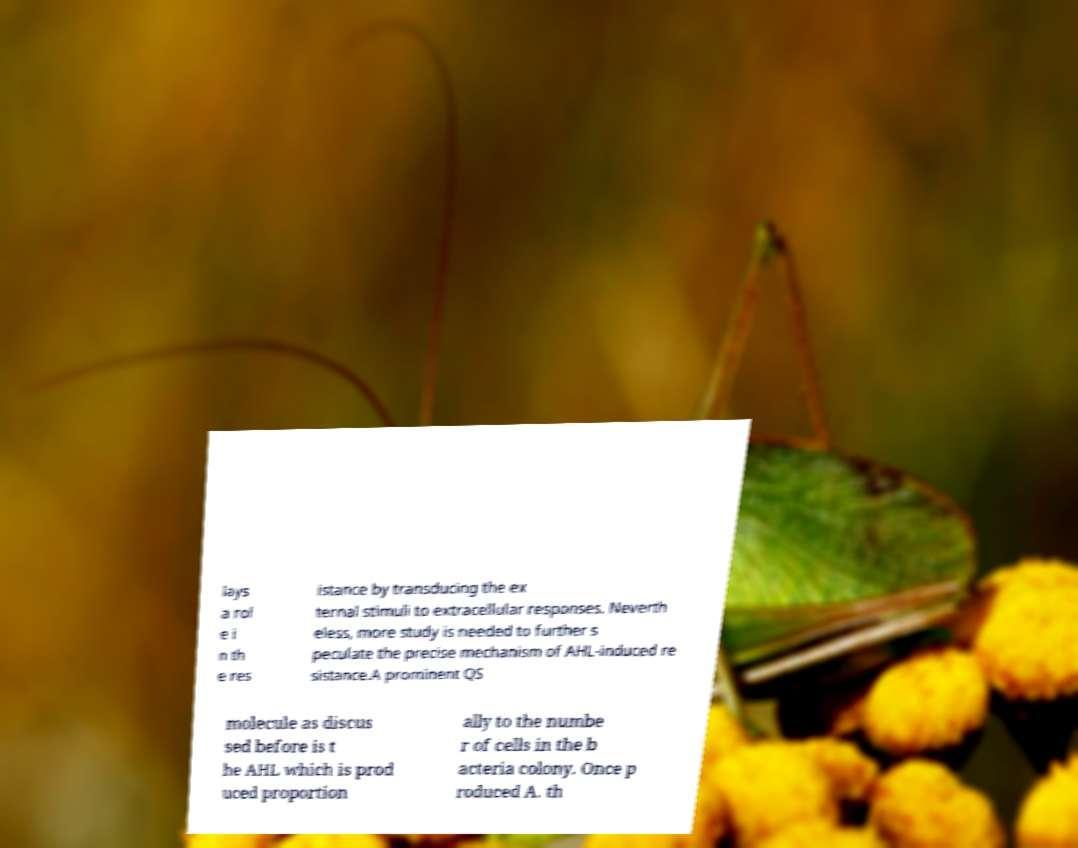What messages or text are displayed in this image? I need them in a readable, typed format. lays a rol e i n th e res istance by transducing the ex ternal stimuli to extracellular responses. Neverth eless, more study is needed to further s peculate the precise mechanism of AHL-induced re sistance.A prominent QS molecule as discus sed before is t he AHL which is prod uced proportion ally to the numbe r of cells in the b acteria colony. Once p roduced A. th 